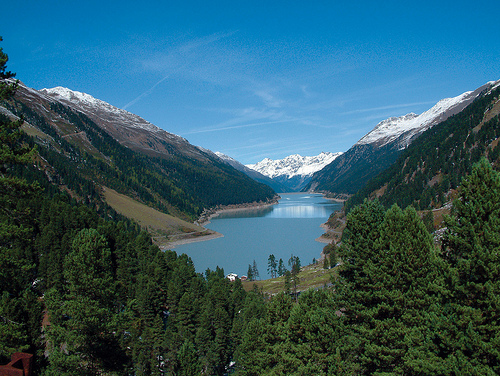<image>
Is there a snow on the mountain? Yes. Looking at the image, I can see the snow is positioned on top of the mountain, with the mountain providing support. Where is the mountain in relation to the mountain? Is it in front of the mountain? No. The mountain is not in front of the mountain. The spatial positioning shows a different relationship between these objects. 